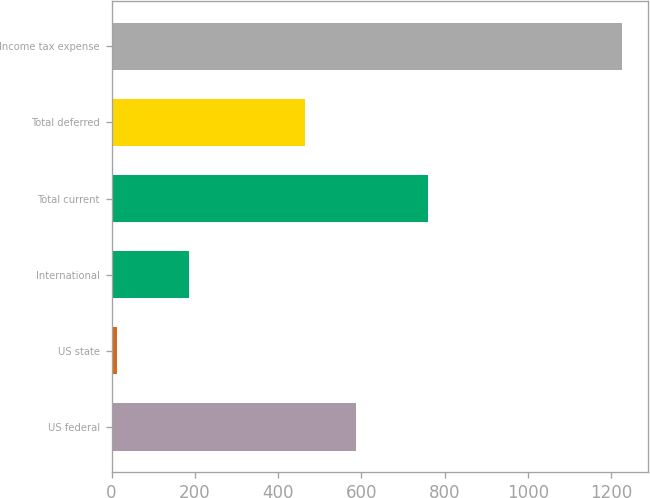Convert chart to OTSL. <chart><loc_0><loc_0><loc_500><loc_500><bar_chart><fcel>US federal<fcel>US state<fcel>International<fcel>Total current<fcel>Total deferred<fcel>Income tax expense<nl><fcel>586.3<fcel>13<fcel>186<fcel>761<fcel>465<fcel>1226<nl></chart> 